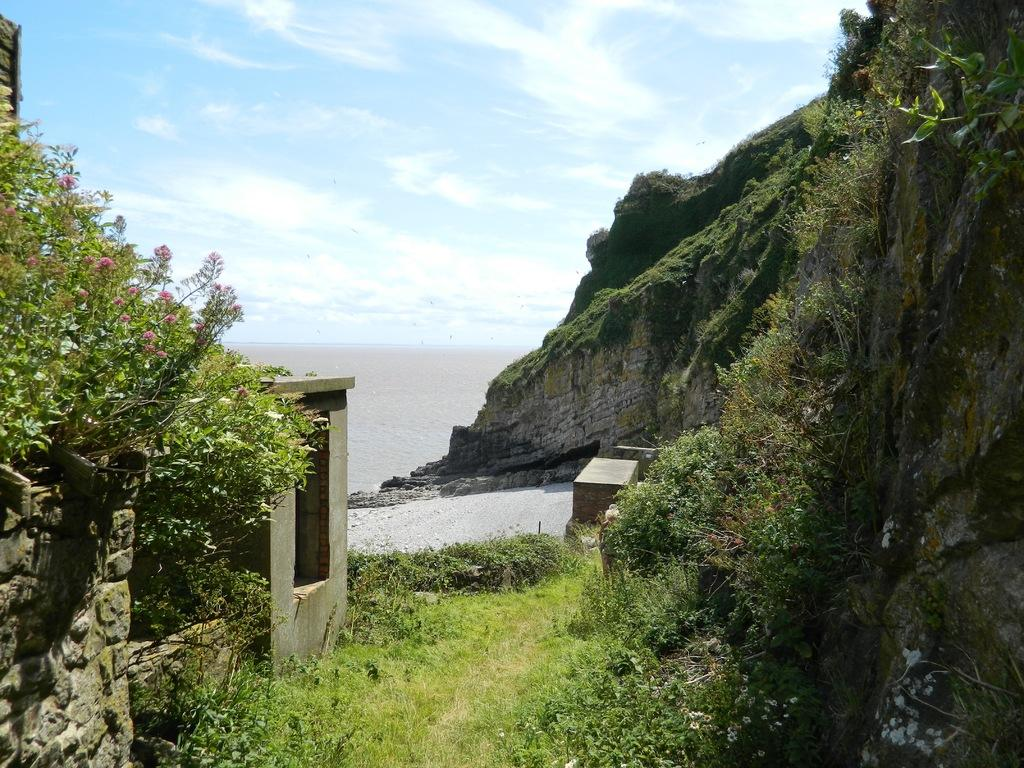What type of vegetation can be seen in the image? There is grass and plants in the image. What geographical feature is present in the image? There is a hill in the image. What natural element can be seen besides the vegetation? There is water visible in the image. What is visible in the background of the image? The sky is visible in the background of the image. What is the committee discussing in the image? There is no committee present in the image, as it features natural elements such as grass, plants, a hill, water, and the sky. 